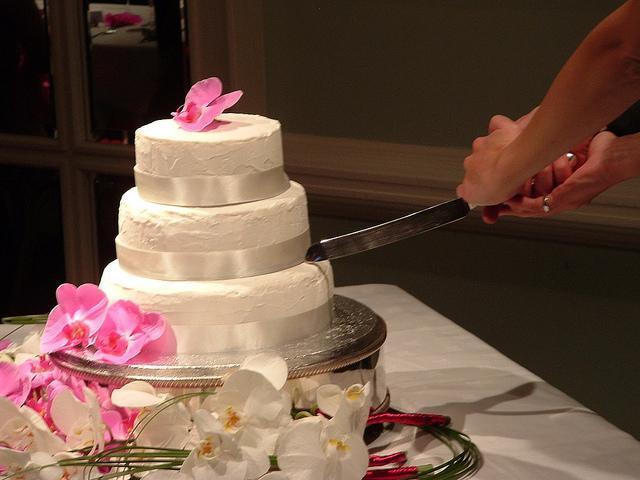How many tiers does the cake have?
Give a very brief answer. 3. How many birds are flying in the picture?
Give a very brief answer. 0. 